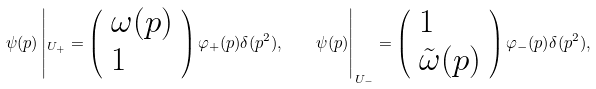Convert formula to latex. <formula><loc_0><loc_0><loc_500><loc_500>\psi ( p ) \left | _ { U _ { + } } = \left ( \begin{array} { l } { \omega ( p ) } \\ { 1 } \end{array} \right ) \varphi _ { + } ( p ) \delta ( p ^ { 2 } ) , \quad \psi ( p ) \right | _ { U _ { - } } = \left ( \begin{array} { l } { 1 } \\ { { \tilde { \omega } ( p ) } } \end{array} \right ) \varphi _ { - } ( p ) \delta ( p ^ { 2 } ) ,</formula> 